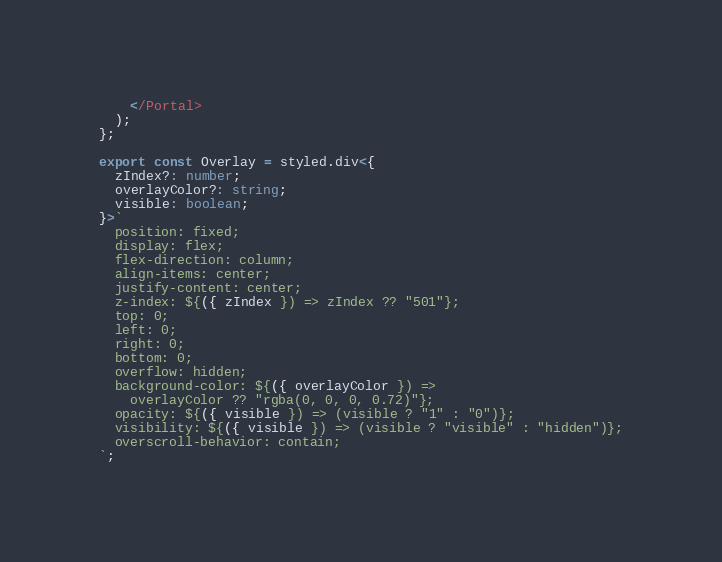Convert code to text. <code><loc_0><loc_0><loc_500><loc_500><_TypeScript_>    </Portal>
  );
};

export const Overlay = styled.div<{
  zIndex?: number;
  overlayColor?: string;
  visible: boolean;
}>`
  position: fixed;
  display: flex;
  flex-direction: column;
  align-items: center;
  justify-content: center;
  z-index: ${({ zIndex }) => zIndex ?? "501"};
  top: 0;
  left: 0;
  right: 0;
  bottom: 0;
  overflow: hidden;
  background-color: ${({ overlayColor }) =>
    overlayColor ?? "rgba(0, 0, 0, 0.72)"};
  opacity: ${({ visible }) => (visible ? "1" : "0")};
  visibility: ${({ visible }) => (visible ? "visible" : "hidden")};
  overscroll-behavior: contain;
`;
</code> 